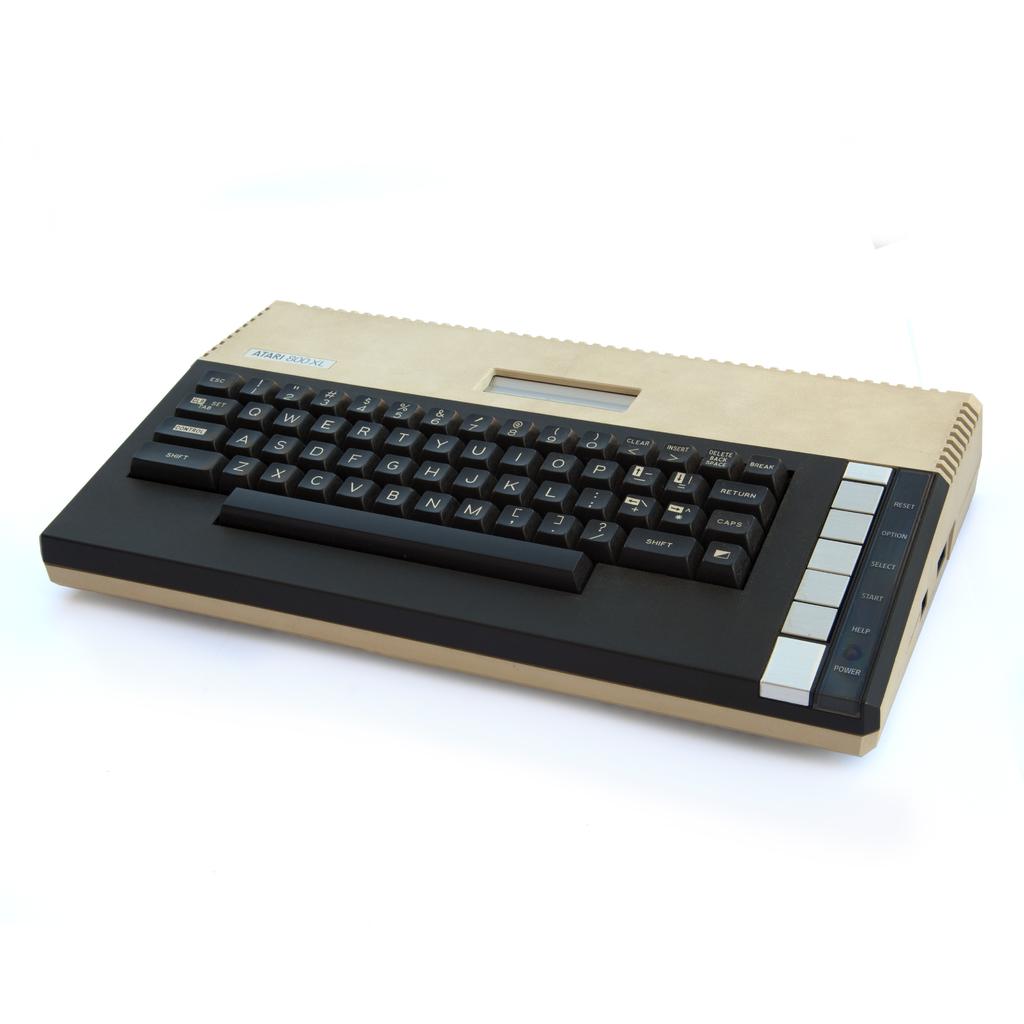What is one of the letters on this device?
Your response must be concise. A. 